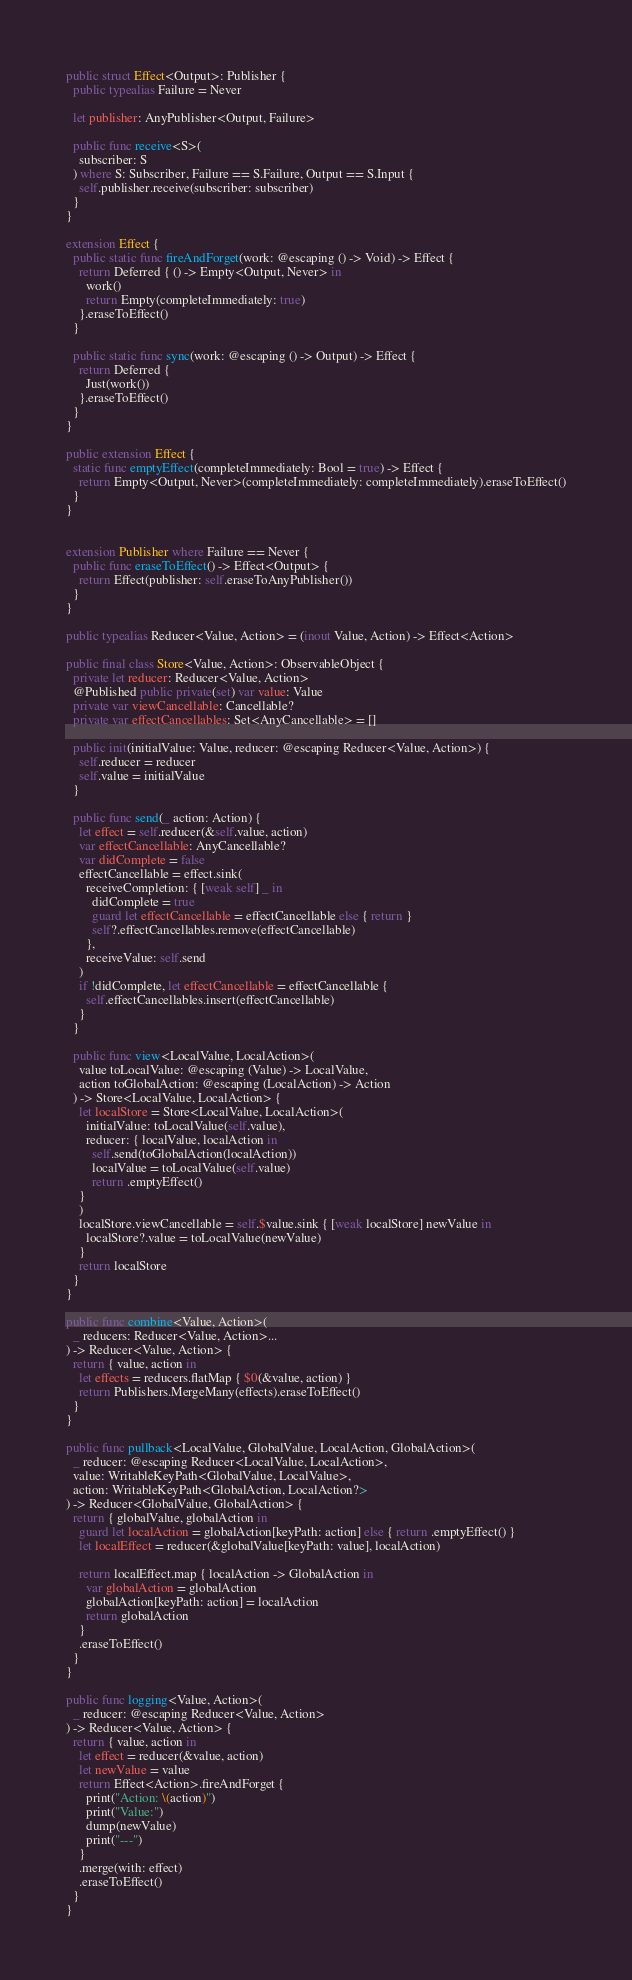Convert code to text. <code><loc_0><loc_0><loc_500><loc_500><_Swift_>
public struct Effect<Output>: Publisher {
  public typealias Failure = Never

  let publisher: AnyPublisher<Output, Failure>

  public func receive<S>(
    subscriber: S
  ) where S: Subscriber, Failure == S.Failure, Output == S.Input {
    self.publisher.receive(subscriber: subscriber)
  }
}

extension Effect {
  public static func fireAndForget(work: @escaping () -> Void) -> Effect {
    return Deferred { () -> Empty<Output, Never> in
      work()
      return Empty(completeImmediately: true)
    }.eraseToEffect()
  }

  public static func sync(work: @escaping () -> Output) -> Effect {
    return Deferred {
      Just(work())
    }.eraseToEffect()
  }
}

public extension Effect {
  static func emptyEffect(completeImmediately: Bool = true) -> Effect {
    return Empty<Output, Never>(completeImmediately: completeImmediately).eraseToEffect()
  }
}


extension Publisher where Failure == Never {
  public func eraseToEffect() -> Effect<Output> {
    return Effect(publisher: self.eraseToAnyPublisher())
  }
}

public typealias Reducer<Value, Action> = (inout Value, Action) -> Effect<Action>

public final class Store<Value, Action>: ObservableObject {
  private let reducer: Reducer<Value, Action>
  @Published public private(set) var value: Value
  private var viewCancellable: Cancellable?
  private var effectCancellables: Set<AnyCancellable> = []

  public init(initialValue: Value, reducer: @escaping Reducer<Value, Action>) {
    self.reducer = reducer
    self.value = initialValue
  }

  public func send(_ action: Action) {
    let effect = self.reducer(&self.value, action)
    var effectCancellable: AnyCancellable?
    var didComplete = false
    effectCancellable = effect.sink(
      receiveCompletion: { [weak self] _ in
        didComplete = true
        guard let effectCancellable = effectCancellable else { return }
        self?.effectCancellables.remove(effectCancellable)
      },
      receiveValue: self.send
    )
    if !didComplete, let effectCancellable = effectCancellable {
      self.effectCancellables.insert(effectCancellable)
    }
  }

  public func view<LocalValue, LocalAction>(
    value toLocalValue: @escaping (Value) -> LocalValue,
    action toGlobalAction: @escaping (LocalAction) -> Action
  ) -> Store<LocalValue, LocalAction> {
    let localStore = Store<LocalValue, LocalAction>(
      initialValue: toLocalValue(self.value),
      reducer: { localValue, localAction in
        self.send(toGlobalAction(localAction))
        localValue = toLocalValue(self.value)
        return .emptyEffect()
    }
    )
    localStore.viewCancellable = self.$value.sink { [weak localStore] newValue in
      localStore?.value = toLocalValue(newValue)
    }
    return localStore
  }
}

public func combine<Value, Action>(
  _ reducers: Reducer<Value, Action>...
) -> Reducer<Value, Action> {
  return { value, action in
    let effects = reducers.flatMap { $0(&value, action) }
    return Publishers.MergeMany(effects).eraseToEffect()
  }
}

public func pullback<LocalValue, GlobalValue, LocalAction, GlobalAction>(
  _ reducer: @escaping Reducer<LocalValue, LocalAction>,
  value: WritableKeyPath<GlobalValue, LocalValue>,
  action: WritableKeyPath<GlobalAction, LocalAction?>
) -> Reducer<GlobalValue, GlobalAction> {
  return { globalValue, globalAction in
    guard let localAction = globalAction[keyPath: action] else { return .emptyEffect() }
    let localEffect = reducer(&globalValue[keyPath: value], localAction)
    
    return localEffect.map { localAction -> GlobalAction in
      var globalAction = globalAction
      globalAction[keyPath: action] = localAction
      return globalAction
    }
    .eraseToEffect()
  }
}

public func logging<Value, Action>(
  _ reducer: @escaping Reducer<Value, Action>
) -> Reducer<Value, Action> {
  return { value, action in
    let effect = reducer(&value, action)
    let newValue = value
    return Effect<Action>.fireAndForget {
      print("Action: \(action)")
      print("Value:")
      dump(newValue)
      print("---")
    }
    .merge(with: effect)
    .eraseToEffect()
  }
}
</code> 